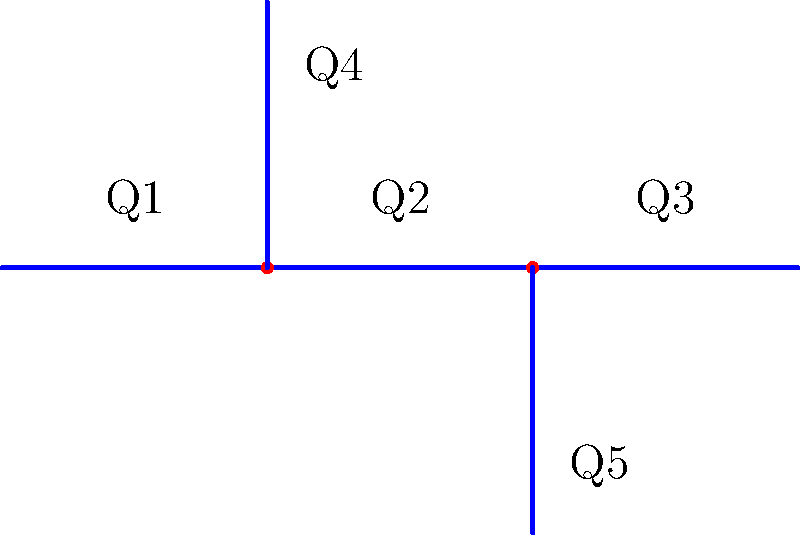In the pipeline system shown above, the flow rates are as follows: Q1 = 100 L/s, Q4 = 30 L/s, and Q5 = 25 L/s. Assuming steady-state conditions and using the principle of conservation of mass, calculate the flow rate Q3 in L/s. To solve this problem, we'll use the principle of conservation of mass, which states that the total mass entering a system must equal the total mass leaving the system under steady-state conditions. In the context of fluid flow, this means that the sum of all inflows must equal the sum of all outflows at each junction.

Let's follow these steps:

1) First, we need to identify the known and unknown flow rates:
   - Known: Q1 = 100 L/s, Q4 = 30 L/s, Q5 = 25 L/s
   - Unknown: Q2 and Q3

2) At the first junction (where Q4 branches off):
   Q1 = Q2 + Q4
   100 = Q2 + 30
   Q2 = 70 L/s

3) At the second junction (where Q5 branches off):
   Q2 = Q3 + Q5
   70 = Q3 + 25

4) Solve for Q3:
   Q3 = 70 - 25 = 45 L/s

Therefore, the flow rate Q3 is 45 L/s.
Answer: 45 L/s 